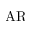Convert formula to latex. <formula><loc_0><loc_0><loc_500><loc_500>A R</formula> 